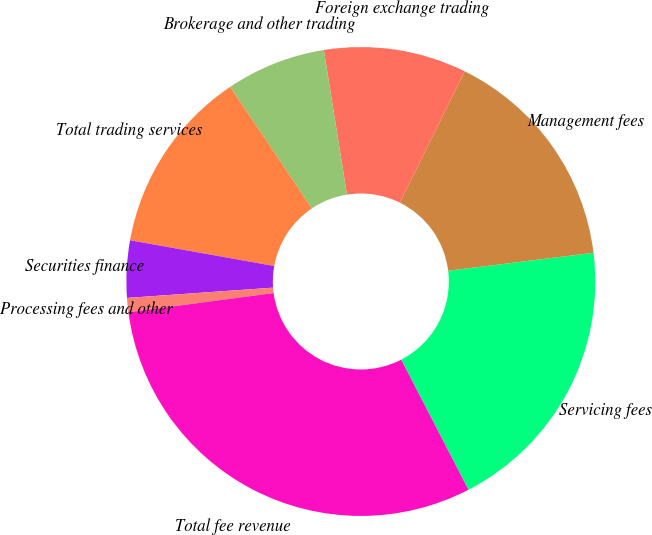Convert chart to OTSL. <chart><loc_0><loc_0><loc_500><loc_500><pie_chart><fcel>Servicing fees<fcel>Management fees<fcel>Foreign exchange trading<fcel>Brokerage and other trading<fcel>Total trading services<fcel>Securities finance<fcel>Processing fees and other<fcel>Total fee revenue<nl><fcel>19.36%<fcel>15.74%<fcel>9.83%<fcel>6.88%<fcel>12.78%<fcel>3.93%<fcel>0.98%<fcel>30.49%<nl></chart> 